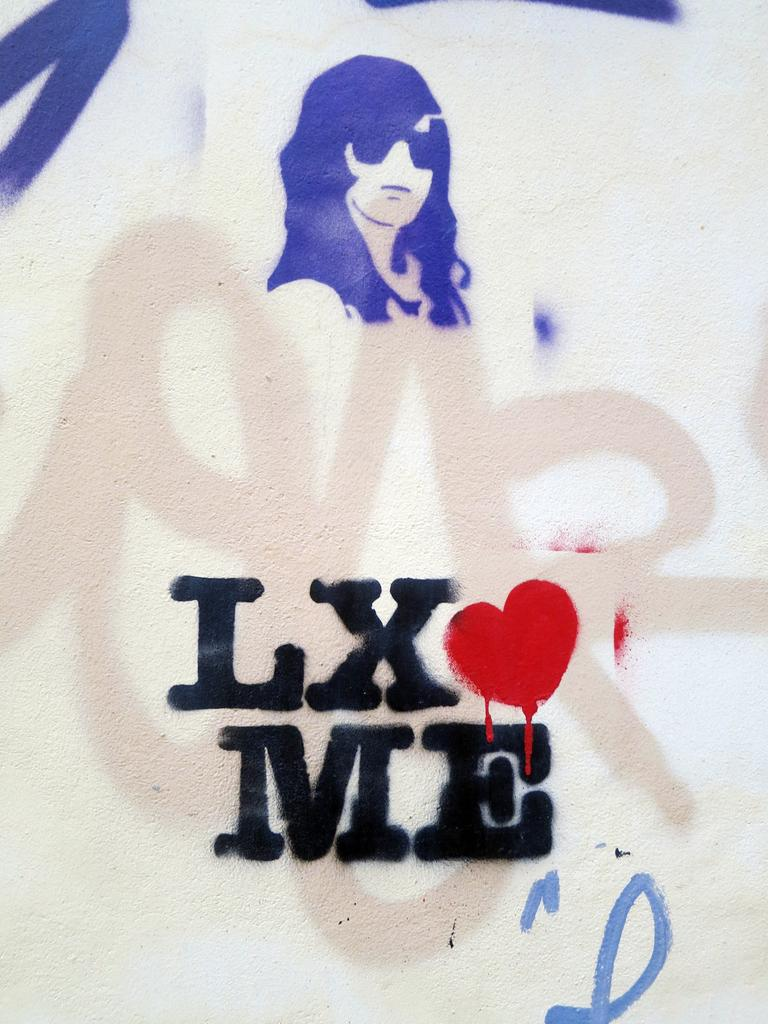What is on the wall in the image? There is a painting on the wall in the image. What type of basin is located next to the painting in the image? There is no basin present in the image; it only features a painting on the wall. 